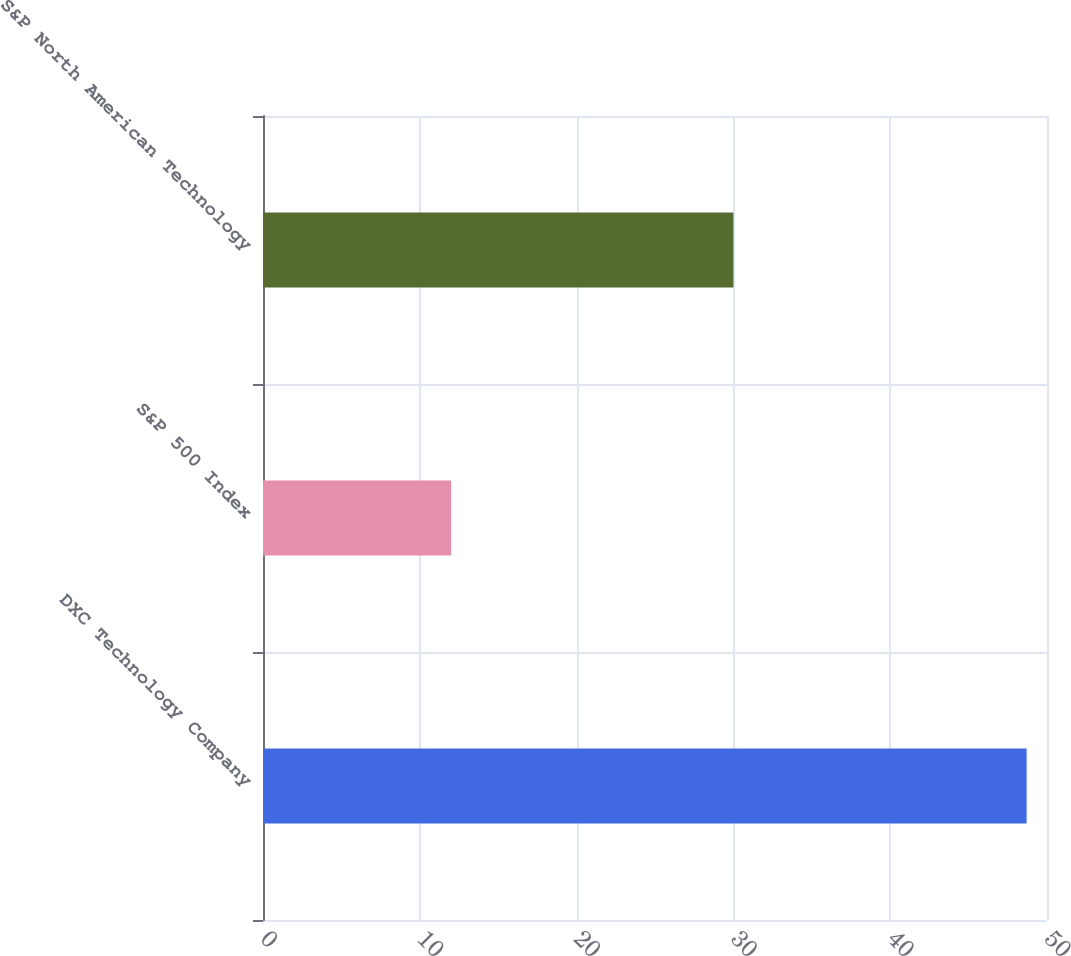Convert chart to OTSL. <chart><loc_0><loc_0><loc_500><loc_500><bar_chart><fcel>DXC Technology Company<fcel>S&P 500 Index<fcel>S&P North American Technology<nl><fcel>48.7<fcel>12<fcel>30<nl></chart> 